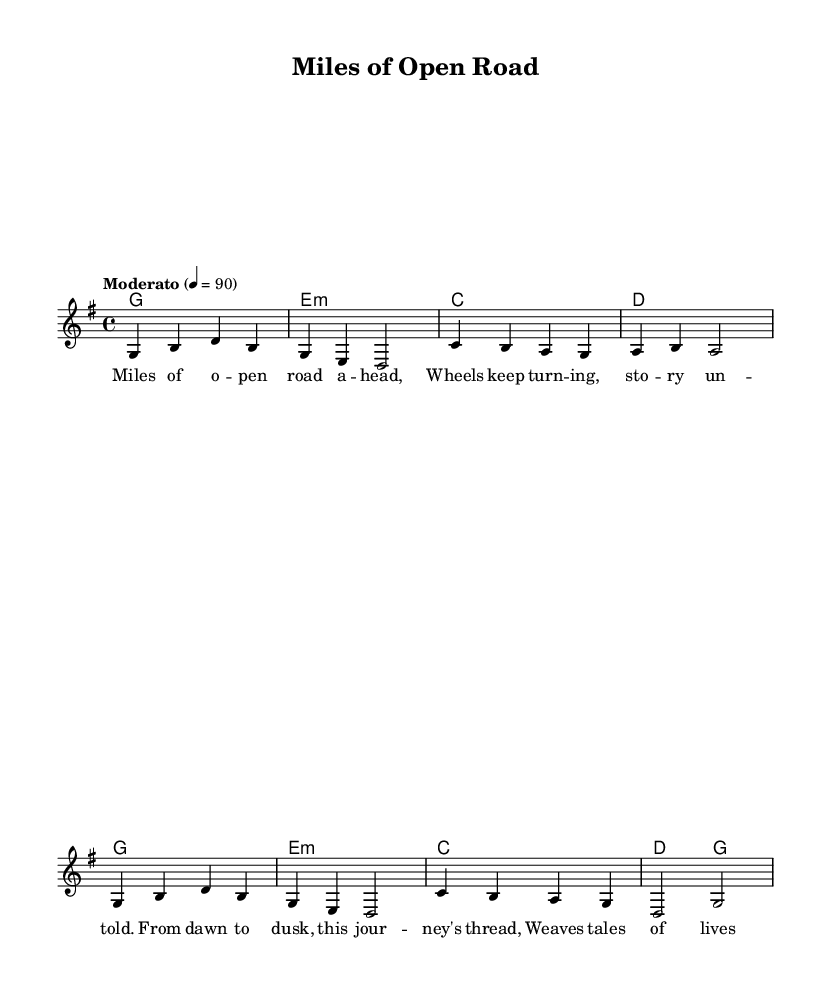What is the key signature of this music? The key signature indicates G major, which has one sharp (F#). This can be confirmed by looking at the key signature marked at the beginning of the score.
Answer: G major What is the time signature of this music? The time signature shown at the beginning of the score is 4/4, which indicates that there are four beats in each measure and the quarter note gets one beat.
Answer: 4/4 What is the tempo of this piece? The tempo marking states "Moderato" and indicates a tempo of 90 beats per minute, which can be seen in the tempo indication at the start of the score.
Answer: 90 How many measures are present in the melody? To find the number of measures, count each group of notes separated by vertical lines in the melody part. There are a total of six measures in the melody.
Answer: 6 What is the first lyric line of the verse? By looking at the lyrics under the melody, the first line reads "Miles of o -- pen road a -- head," which is the first text aligned with the melody notes.
Answer: Miles of o -- pen road a -- head Why is this song categorized as a Folk ballad? The song is categorized as a Folk ballad because it tells a story about long-distance journeys and everyday experiences, common themes in folk music that reflect life on the road. This thematic focus aligns with traditional folk characteristics.
Answer: Storytelling What chords are used in the harmonies? The chords can be identified in the chord names section, where the progression includes G, E minor, C, and D. Each chord corresponds to the measures of harmony listed.
Answer: G, E minor, C, D 